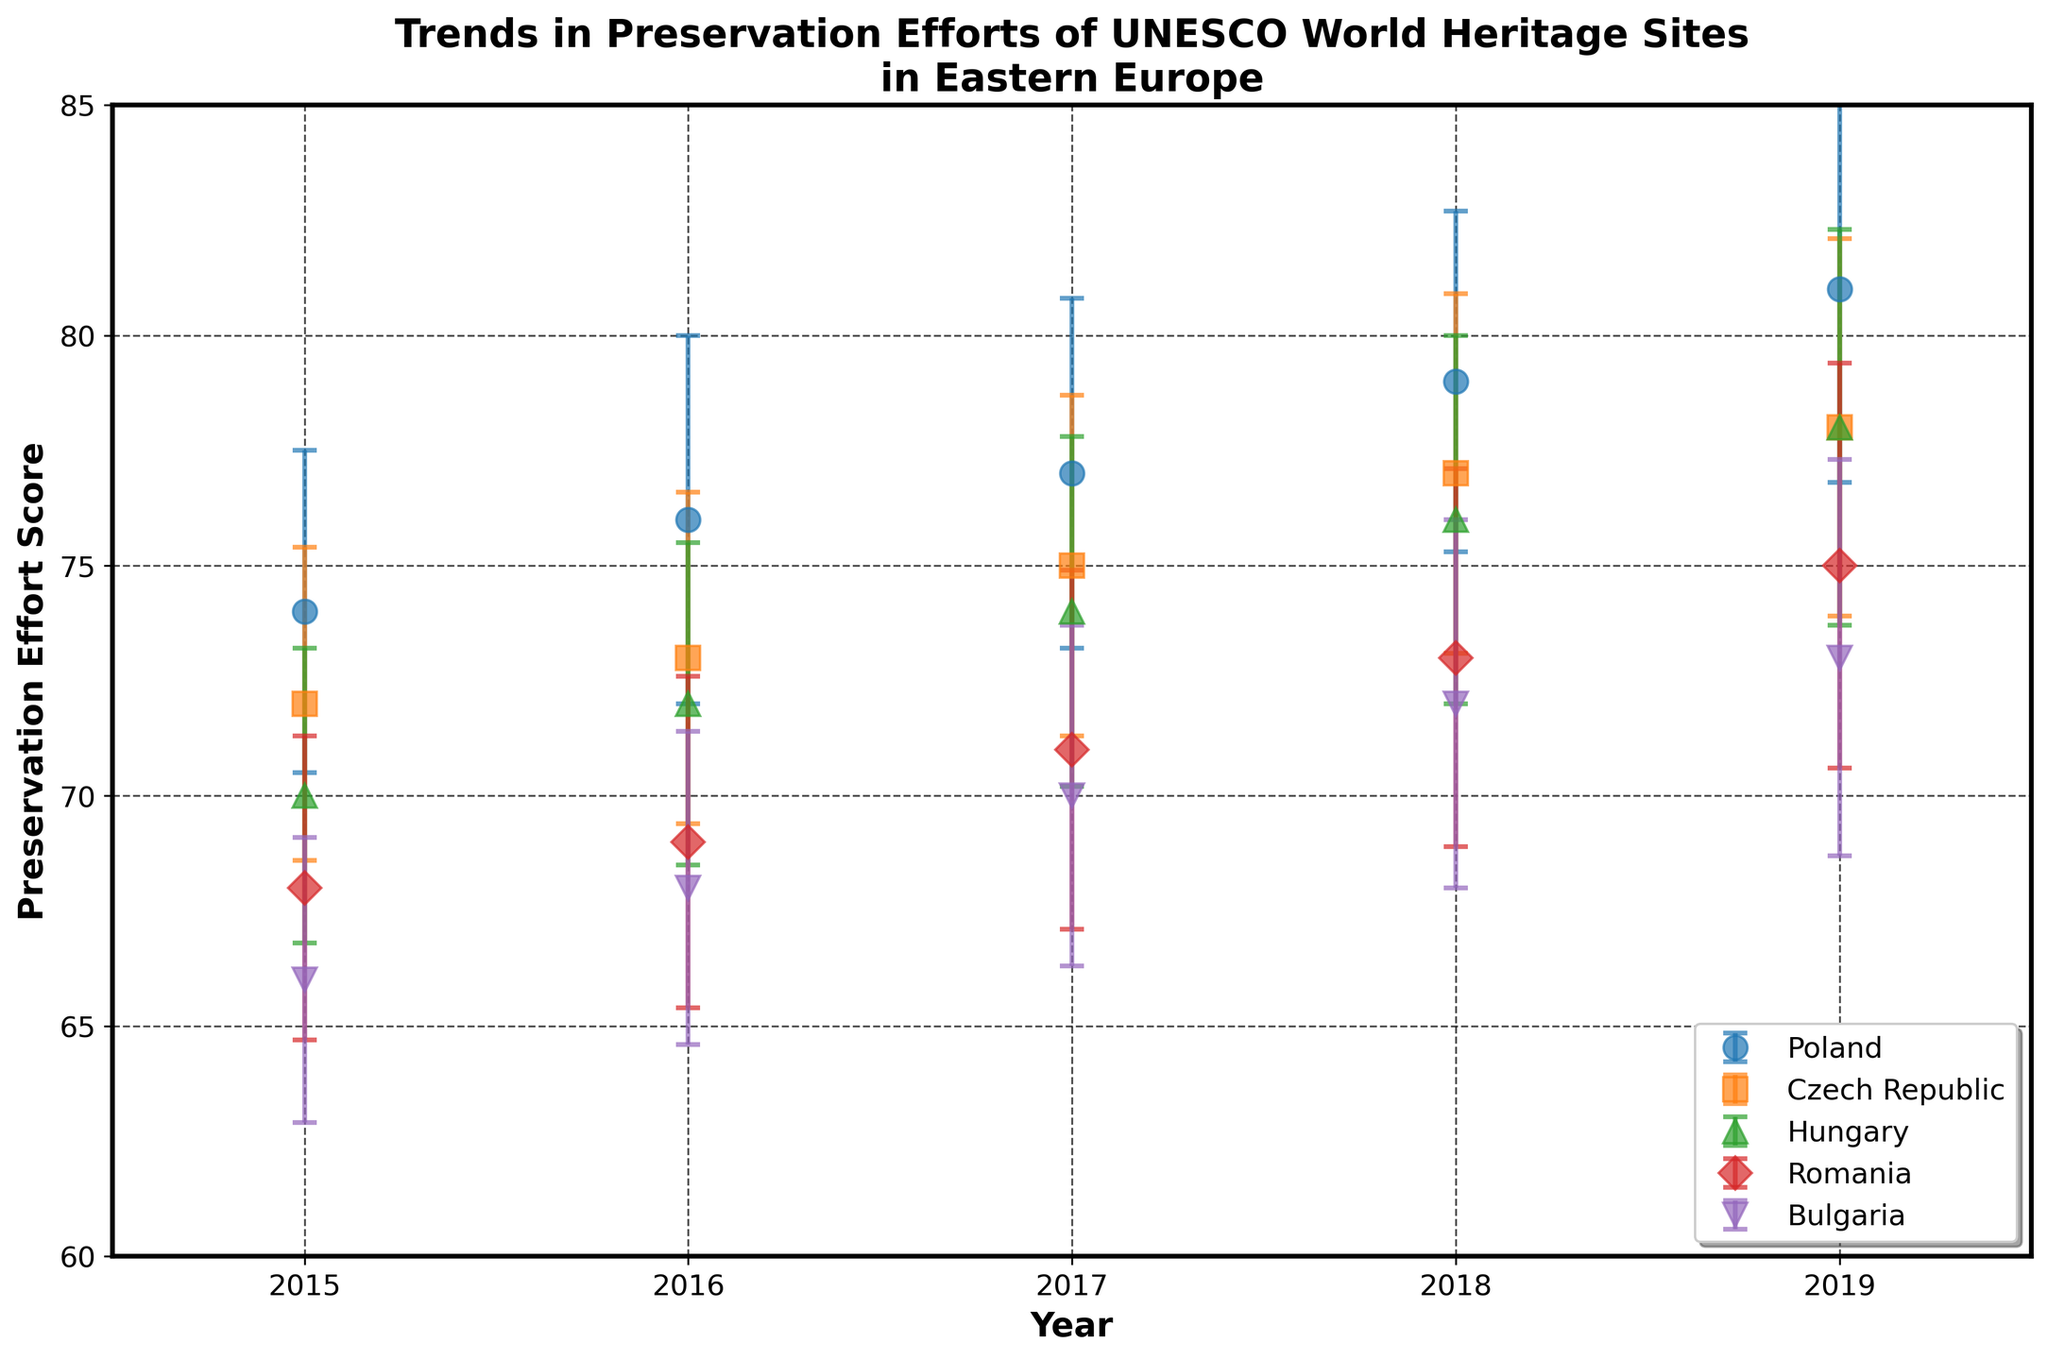What is the title of the figure? The title is at the top of the figure and contains descriptive information about the topic of the plot.
Answer: Trends in Preservation Efforts of UNESCO World Heritage Sites in Eastern Europe How many countries are represented in the figure? Count the number of unique markers and labels in the legend to determine the number of countries.
Answer: Five Which country shows the highest Preservation Effort Score in 2019? Locate the data points for the year 2019 on the x-axis and compare the y-axis values (Preservation Effort Scores) for each country.
Answer: Poland Which country shows the lowest Preservation Effort Score in 2015? Locate the data points for the year 2015 on the x-axis and compare the y-axis values for each country.
Answer: Bulgaria What is the range of Preservation Effort Scores observed in 2019? Identify the highest and lowest data points for the year 2019 and calculate the difference between them.
Answer: 73 to 81 How does the Preservation Effort Score for the Czech Republic change from 2015 to 2019? Identify the data points for the Czech Republic in 2015 and 2019, and then calculate the difference between these two scores.
Answer: It increased by 6 points (72 in 2015 to 78 in 2019) Which country has the smallest standard deviation in 2017? Compare the error bars for each country in 2017 and determine which one is the smallest.
Answer: Poland Which country shows the most consistent trend in terms of Preservation Effort Score from 2015 to 2019? Look for the country where the data points form the most linear and least variable trend over the years.
Answer: Poland Do any countries show overlapping Preservation Effort Scores with their error bars in 2019? Look at the 2019 data points and error bars to see if the error ranges overlap for any countries.
Answer: Yes, Hungary and Romania What is the average Preservation Effort Score for Bulgaria across all years? Sum the Preservation Effort Scores for Bulgaria for each year and divide by the number of years (5).
Answer: (66 + 68 + 70 + 72 + 73)/5 = 69.8 